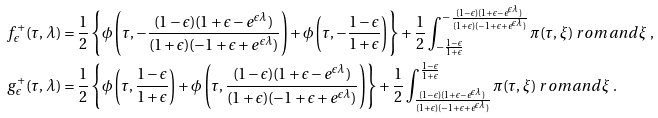Convert formula to latex. <formula><loc_0><loc_0><loc_500><loc_500>f ^ { + } _ { \epsilon } ( \tau , \lambda ) & = \frac { 1 } { 2 } \left \{ \phi \left ( \tau , - \frac { ( 1 - \epsilon ) ( 1 + \epsilon - e ^ { \epsilon \lambda } ) } { ( 1 + \epsilon ) ( - 1 + \epsilon + e ^ { \epsilon \lambda } ) } \right ) + \phi \left ( \tau , - \frac { 1 - \epsilon } { 1 + \epsilon } \right ) \right \} + \frac { 1 } { 2 } \int _ { - \frac { 1 - \epsilon } { 1 + \epsilon } } ^ { - \frac { ( 1 - \epsilon ) ( 1 + \epsilon - e ^ { \epsilon \lambda } ) } { ( 1 + \epsilon ) ( - 1 + \epsilon + e ^ { \epsilon \lambda } ) } } \pi ( \tau , \xi ) \ r o m a n d \xi \ , \\ g ^ { + } _ { \epsilon } ( \tau , \lambda ) & = \frac { 1 } { 2 } \left \{ \phi \left ( \tau , \frac { 1 - \epsilon } { 1 + \epsilon } \right ) + \phi \left ( \tau , \frac { ( 1 - \epsilon ) ( 1 + \epsilon - e ^ { \epsilon \lambda } ) } { ( 1 + \epsilon ) ( - 1 + \epsilon + e ^ { \epsilon \lambda } ) } \right ) \right \} + \frac { 1 } { 2 } \int ^ { \frac { 1 - \epsilon } { 1 + \epsilon } } _ { \frac { ( 1 - \epsilon ) ( 1 + \epsilon - e ^ { \epsilon \lambda } ) } { ( 1 + \epsilon ) ( - 1 + \epsilon + e ^ { \epsilon \lambda } ) } } \pi ( \tau , \xi ) \ r o m a n d \xi \ .</formula> 